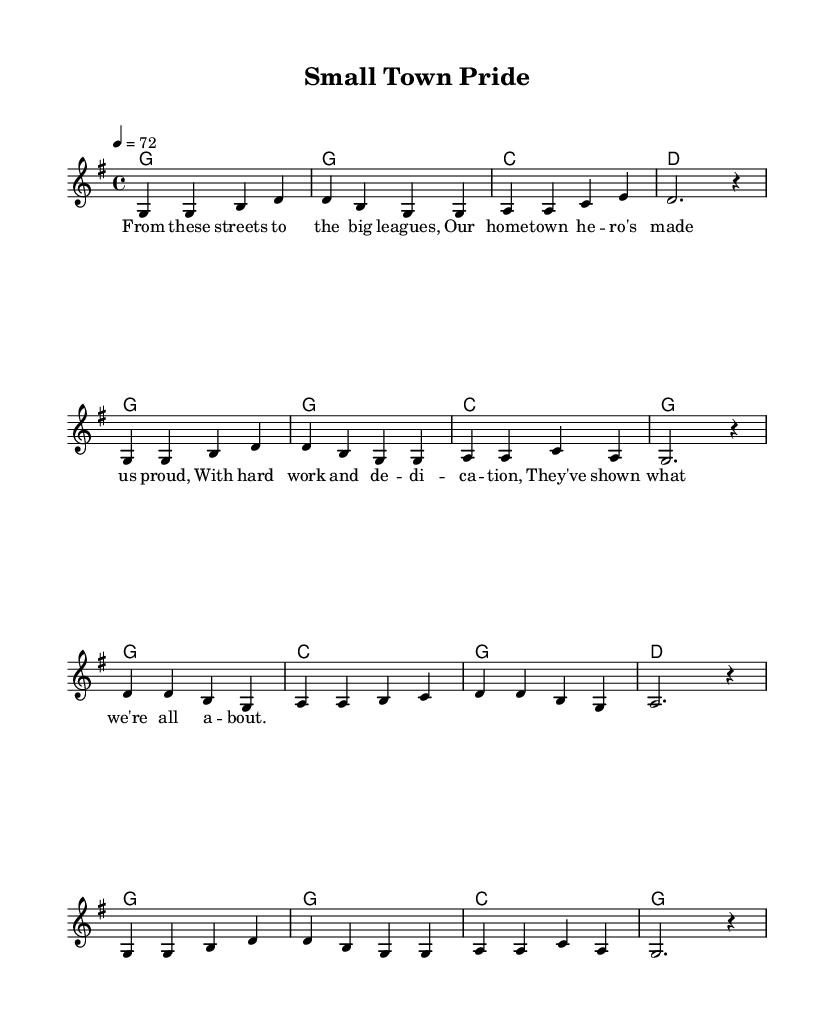What is the key signature of this music? The key signature is G major, which has one sharp (F#). This is identifiable in the starting section labeled with "\key g \major".
Answer: G major What is the time signature of this music? The time signature is 4/4, which means there are four beats in each measure. This is specified by "\time 4/4".
Answer: 4/4 What is the tempo marking for this music? The tempo marking indicates a speed of 72 beats per minute, which can be found under "\tempo 4 = 72".
Answer: 72 How many measures are in the melody section? The melody section contains 8 measures. This can be counted from the grouped notes, where each group is separated by the vertical lines in the music sheet.
Answer: 8 What type of song is this classified as? This song is classified as a patriotic country ballad, as derived from the title "Small Town Pride" and the lyrical themes that celebrate local heroes and their achievements.
Answer: patriotic country ballad What is the first phrase of the lyrics? The first phrase of the lyrics is "From these streets to the big leagues," which appears at the beginning of the lyric section.
Answer: From these streets to the big leagues Which chord is played in the first measure? The chord played in the first measure is G major, indicated by the notation "g1" in the harmonies section.
Answer: G 